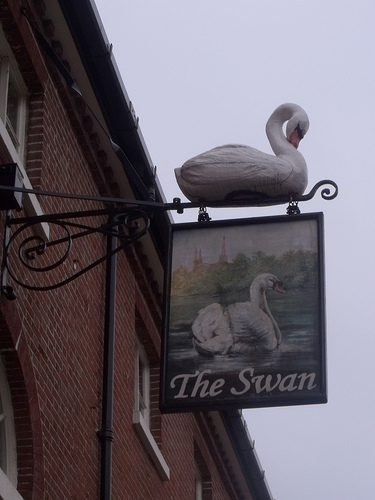<image>
Is there a swan on the sign? Yes. Looking at the image, I can see the swan is positioned on top of the sign, with the sign providing support. Where is the sign in relation to the swan? Is it in front of the swan? No. The sign is not in front of the swan. The spatial positioning shows a different relationship between these objects. 